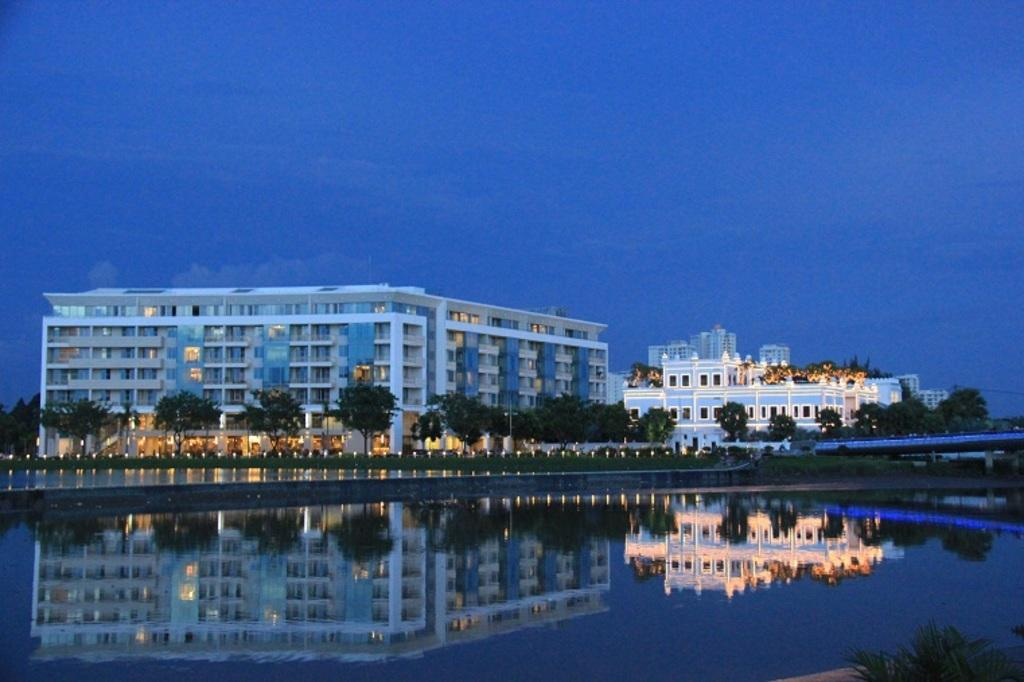What is located in the center of the image? There are buildings in the center of the image. What can be seen at the bottom of the image? Trees and a lake are visible at the bottom of the image. What is visible at the top of the image? The sky is visible at the top of the image. What type of butter is being used to frame the buildings in the image? There is no butter or framing present in the image; it features buildings, trees, a lake, and the sky. 